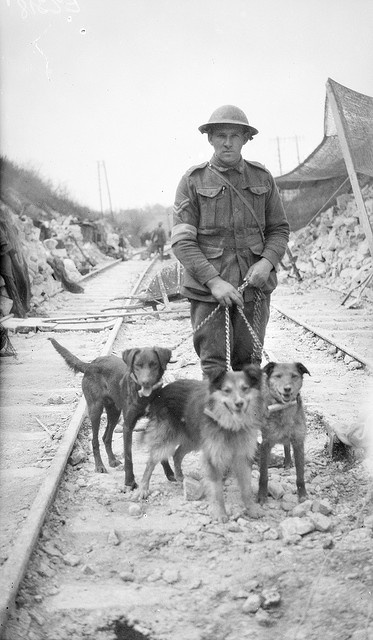Describe the objects in this image and their specific colors. I can see people in lightgray, gray, darkgray, and black tones, dog in lightgray, darkgray, gray, and black tones, dog in lightgray, gray, darkgray, and black tones, dog in lightgray, gray, darkgray, and black tones, and people in darkgray, gray, and lightgray tones in this image. 